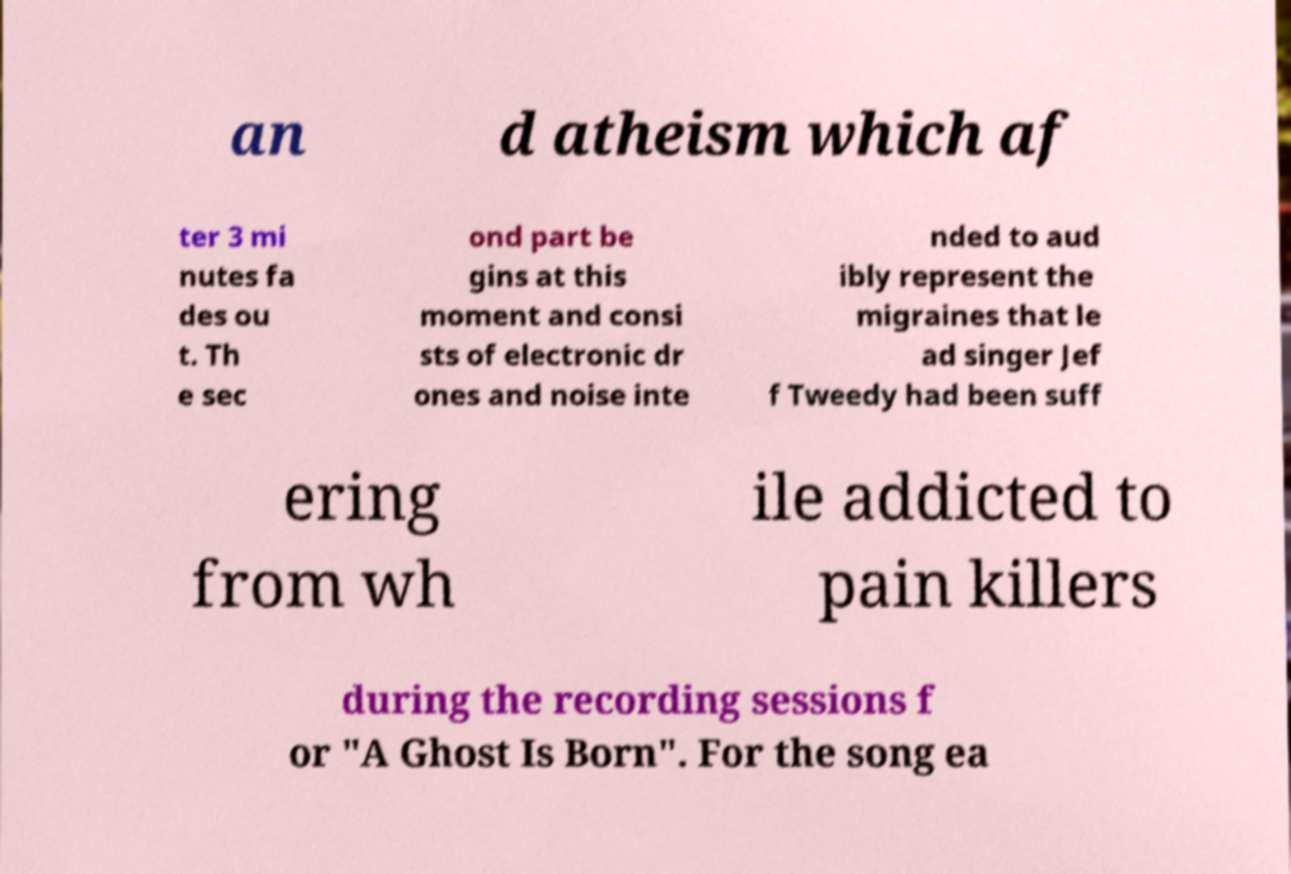For documentation purposes, I need the text within this image transcribed. Could you provide that? an d atheism which af ter 3 mi nutes fa des ou t. Th e sec ond part be gins at this moment and consi sts of electronic dr ones and noise inte nded to aud ibly represent the migraines that le ad singer Jef f Tweedy had been suff ering from wh ile addicted to pain killers during the recording sessions f or "A Ghost Is Born". For the song ea 